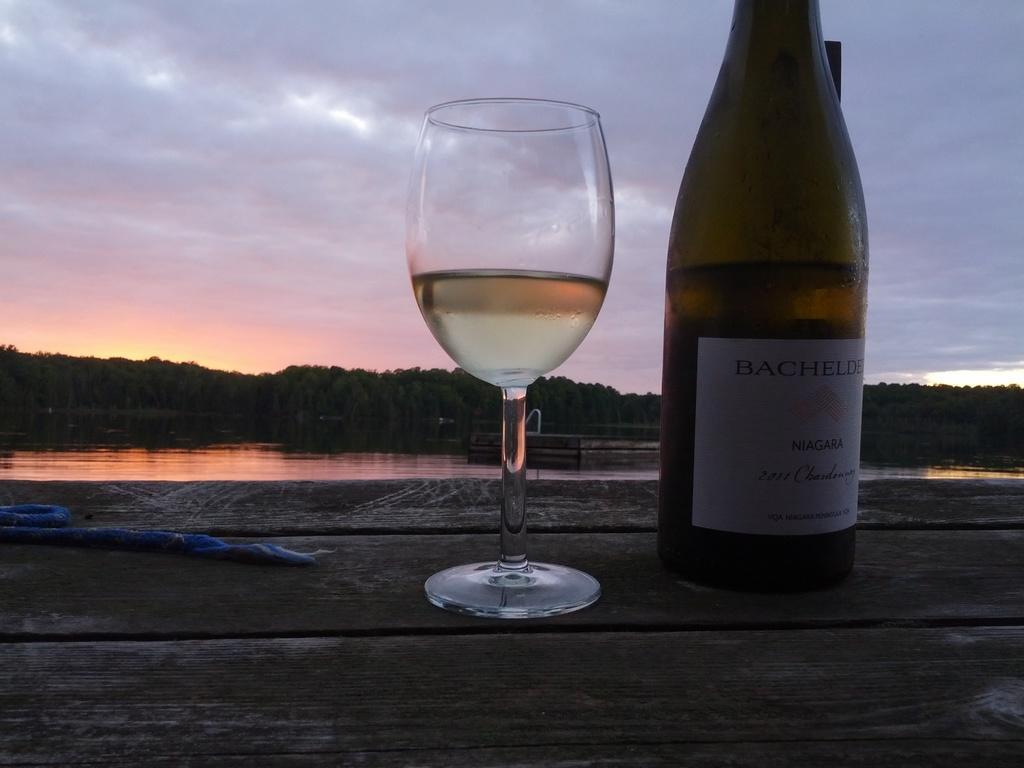Could you give a brief overview of what you see in this image? In this picture we can see glass with drink in it, bottle with sticker to it placed on a wooden platform and in background we can see trees, water, sky with clouds. 